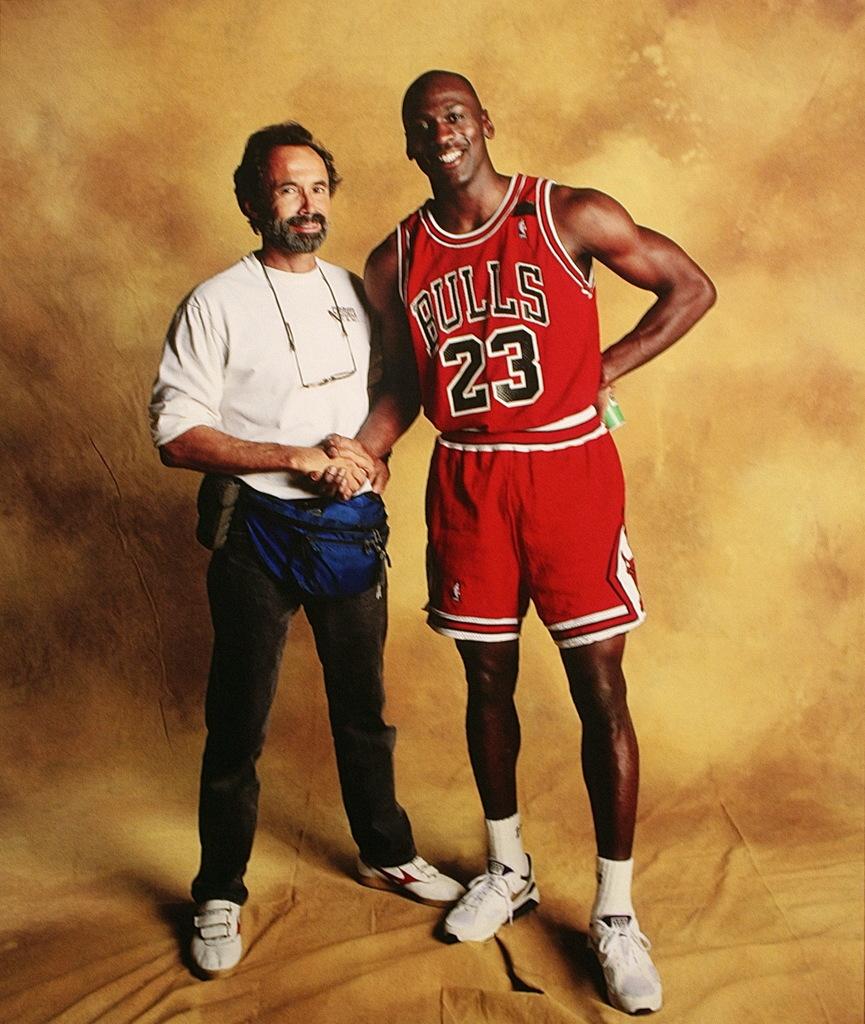What is his jersey number?
Ensure brevity in your answer.  23. 